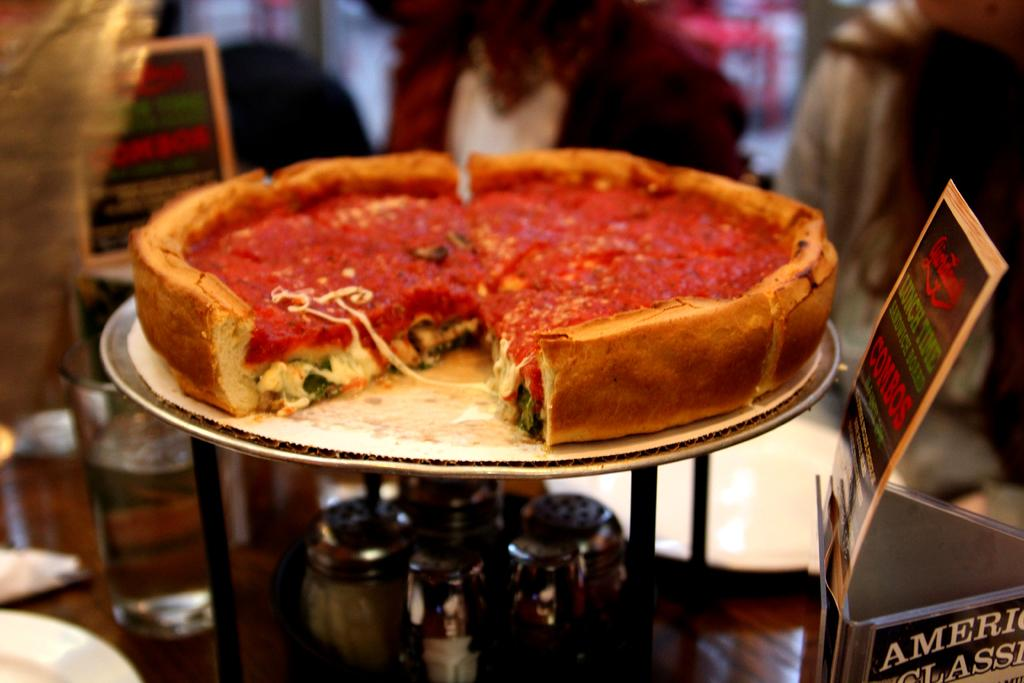What type of food is the main subject of the image? There is a pizza in the image. How is the pizza presented? The pizza is on a plate. What other items can be seen on the table? There are glasses and bottles on the table. Can you describe the people visible in the background of the image? There are people visible in the background of the image, but their specific characteristics are not mentioned in the provided facts. What color of paint is being used to decorate the key in the image? There is no key or paint present in the image. How many bottles are visible in the image? The provided facts do not specify the exact number of bottles visible in the image, only that there are bottles on the table. 